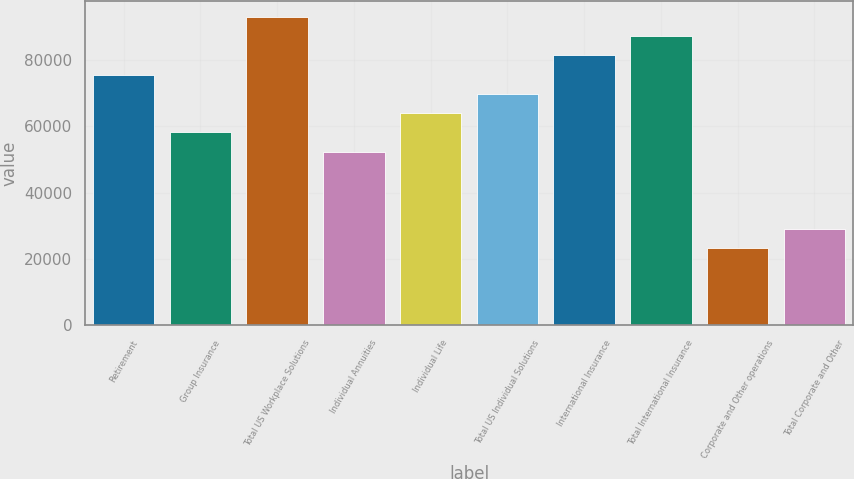Convert chart. <chart><loc_0><loc_0><loc_500><loc_500><bar_chart><fcel>Retirement<fcel>Group Insurance<fcel>Total US Workplace Solutions<fcel>Individual Annuities<fcel>Individual Life<fcel>Total US Individual Solutions<fcel>International Insurance<fcel>Total International Insurance<fcel>Corporate and Other operations<fcel>Total Corporate and Other<nl><fcel>75567.5<fcel>58130<fcel>93005.1<fcel>52317.5<fcel>63942.5<fcel>69755<fcel>81380.1<fcel>87192.6<fcel>23254.9<fcel>29067.4<nl></chart> 